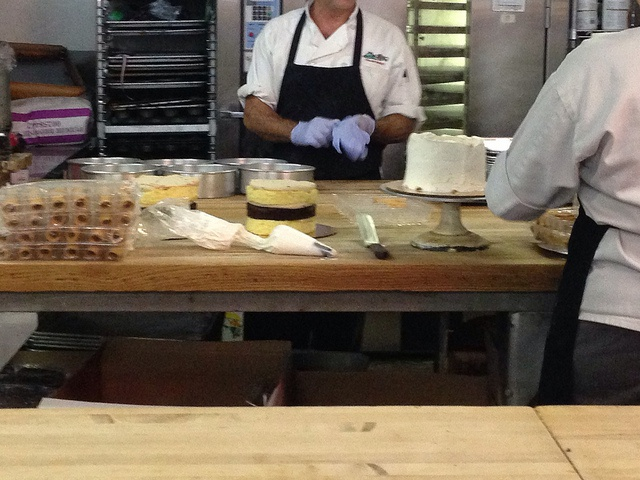Describe the objects in this image and their specific colors. I can see people in gray, darkgray, and black tones, people in gray, black, lightgray, and darkgray tones, cake in gray, darkgray, beige, and tan tones, cake in gray, black, and tan tones, and cake in gray, tan, and khaki tones in this image. 